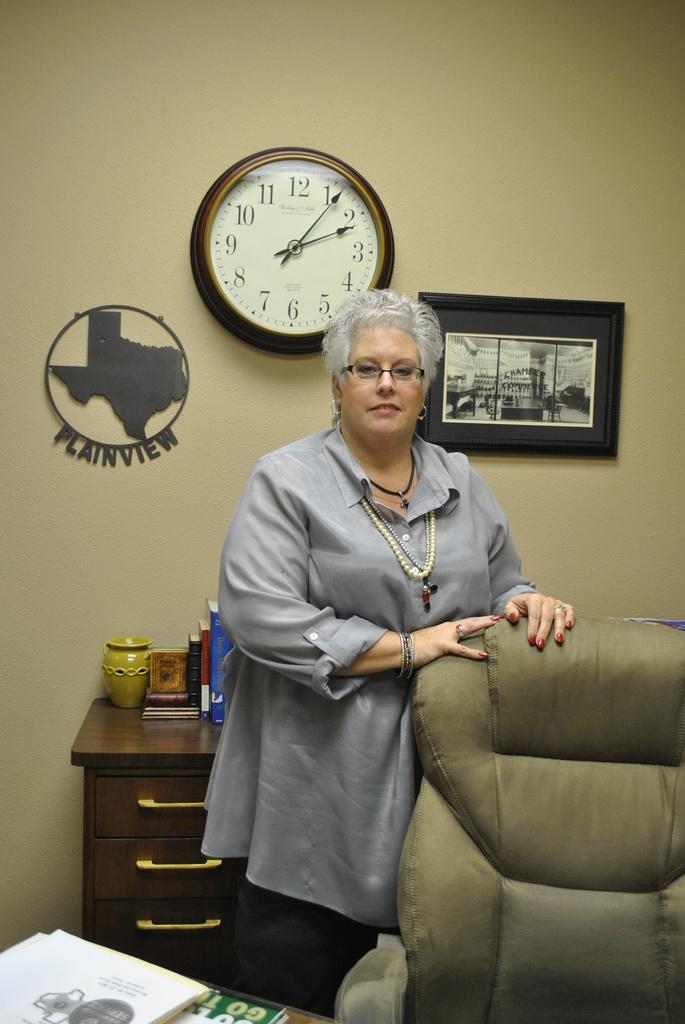What time is it?
Give a very brief answer. 2:06. 